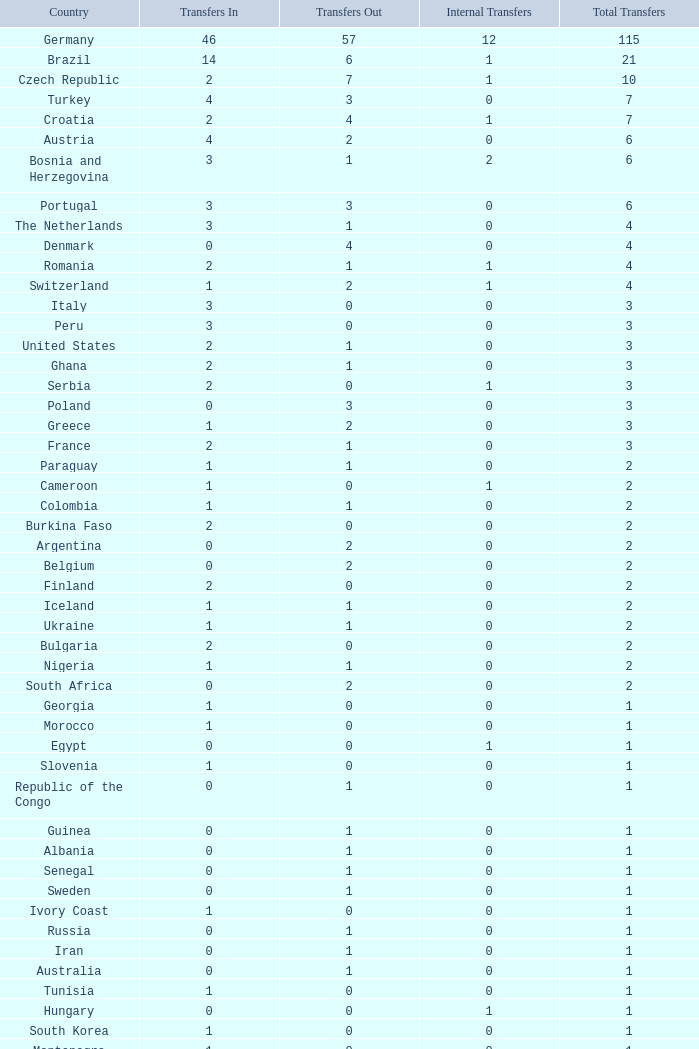What are the disbursements out for peru? 0.0. 